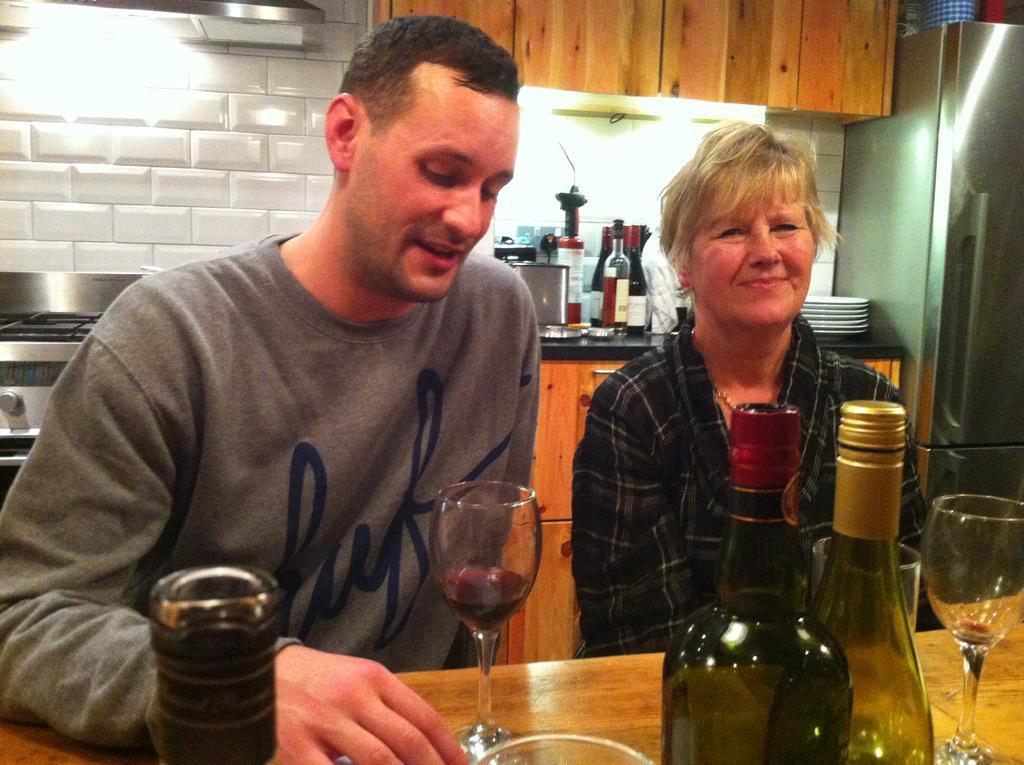In one or two sentences, can you explain what this image depicts? In the middle of the image two persons are sitting and smiling. Top right side of the image there is a refrigerator and there is a cupboard. Bottom of the image there is a table on the table there are some bottles and glasses. Top left side of the image there is wall. 